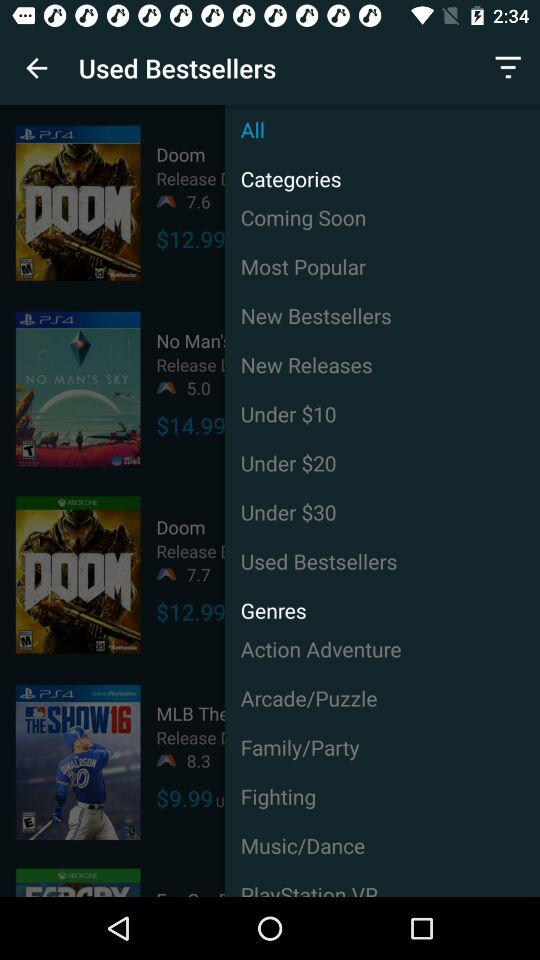What is the ticket price for "Doom"? The ticket price for "Doom" is $12.99. 